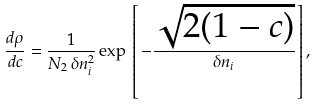<formula> <loc_0><loc_0><loc_500><loc_500>\frac { d \rho } { d c } = \frac { 1 } { N _ { 2 } \, \delta n ^ { 2 } _ { i } } \exp \, \left [ \, - \frac { \sqrt { 2 ( 1 - c ) } } { \delta n _ { i } } \right ] ,</formula> 